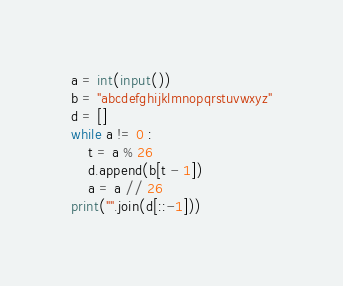Convert code to text. <code><loc_0><loc_0><loc_500><loc_500><_Python_>a = int(input())
b = "abcdefghijklmnopqrstuvwxyz"
d = []
while a != 0 :
    t = a % 26
    d.append(b[t - 1])
    a = a // 26
print("".join(d[::-1]))</code> 